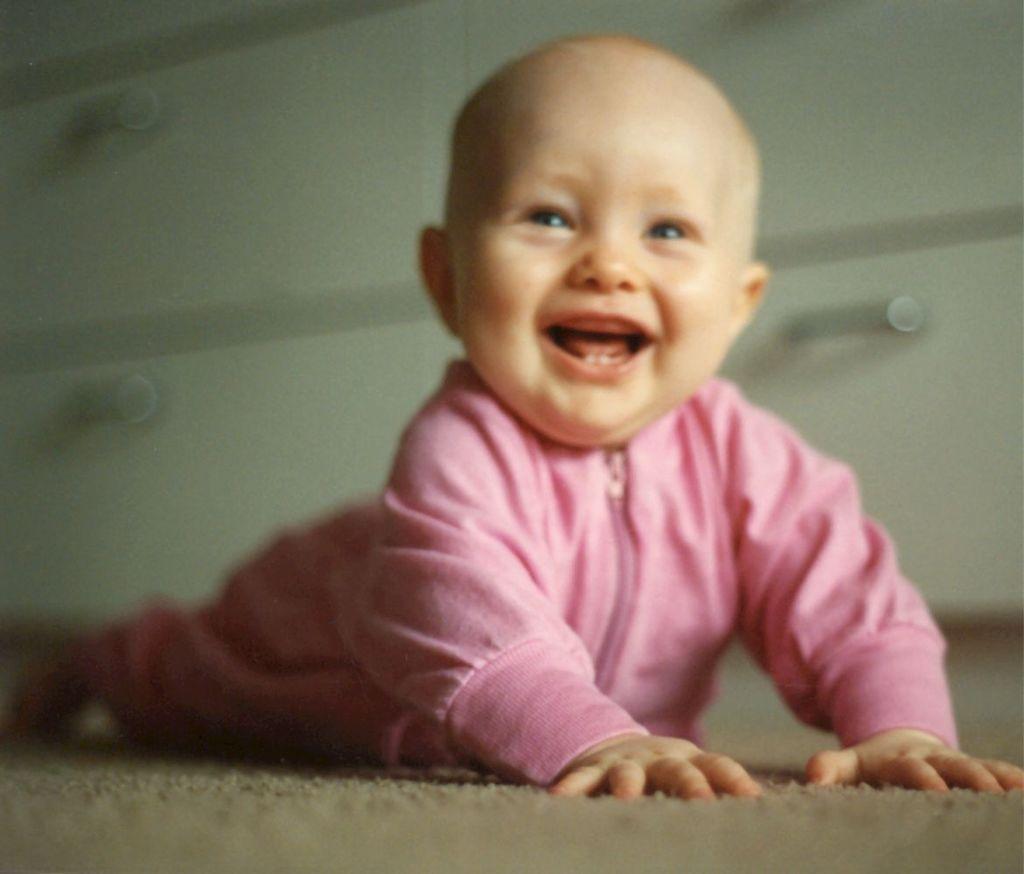Could you give a brief overview of what you see in this image? In this image there is a baby on a floor, in the background it is blurred. 